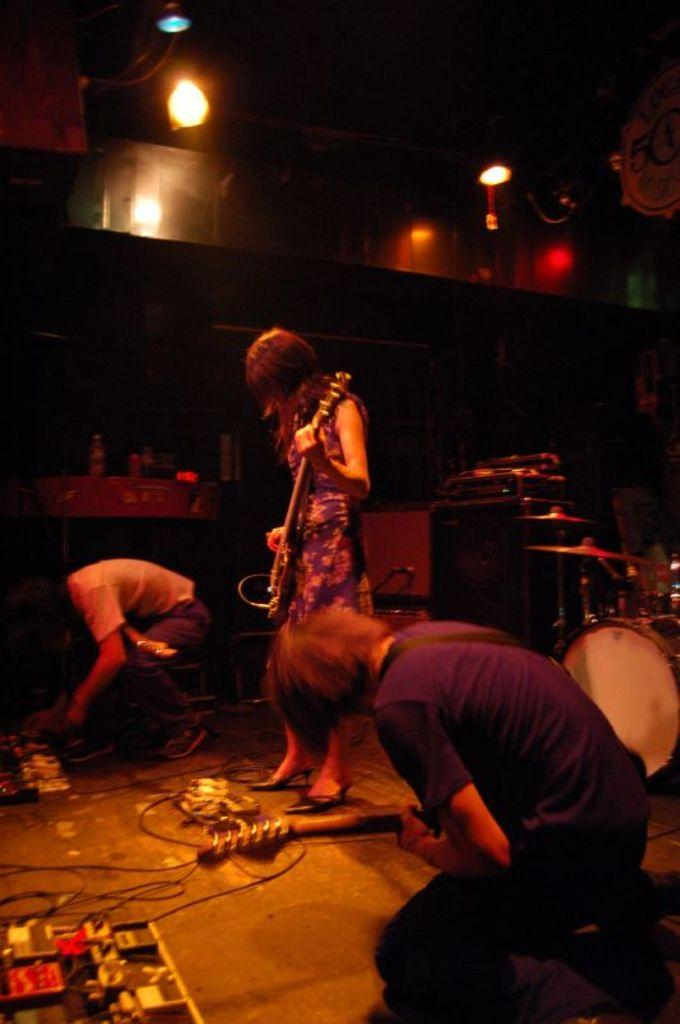Who or what can be seen in the image? There are people in the image. What are the people doing in the image? The people are standing on the floor and holding musical instruments. What type of pest can be seen crawling on the leg of one of the people in the image? There is no pest visible in the image, and no one's leg is shown. 